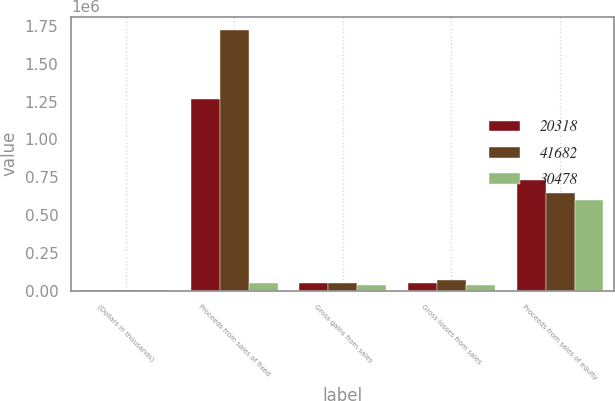<chart> <loc_0><loc_0><loc_500><loc_500><stacked_bar_chart><ecel><fcel>(Dollars in thousands)<fcel>Proceeds from sales of fixed<fcel>Gross gains from sales<fcel>Gross losses from sales<fcel>Proceeds from sales of equity<nl><fcel>20318<fcel>2016<fcel>1.26427e+06<fcel>53093<fcel>47761<fcel>729782<nl><fcel>41682<fcel>2015<fcel>1.72592e+06<fcel>47899<fcel>70185<fcel>642980<nl><fcel>30478<fcel>2014<fcel>50496<fcel>37427<fcel>36156<fcel>600970<nl></chart> 